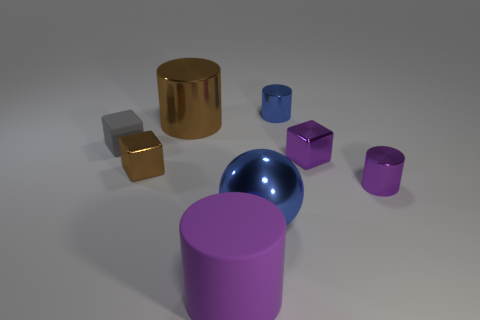Can you describe the shapes and colors of the objects in the image? Certainly! The image features geometric shapes in an array of colors. We have a golden cylinder, a purple cube, a reflective blue sphere, a small silver cube, another cylinder in reflective gold, and a magenta-colored cylinder. 